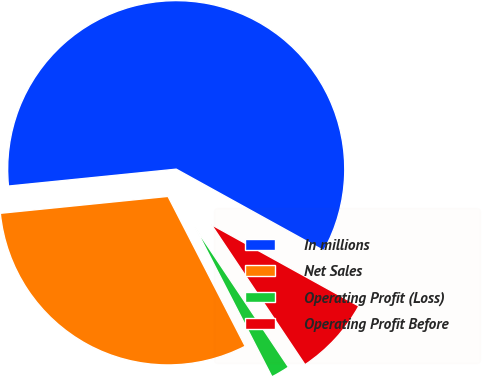Convert chart to OTSL. <chart><loc_0><loc_0><loc_500><loc_500><pie_chart><fcel>In millions<fcel>Net Sales<fcel>Operating Profit (Loss)<fcel>Operating Profit Before<nl><fcel>59.63%<fcel>30.97%<fcel>1.81%<fcel>7.59%<nl></chart> 